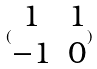<formula> <loc_0><loc_0><loc_500><loc_500>( \begin{matrix} 1 & 1 \\ - 1 & 0 \end{matrix} )</formula> 